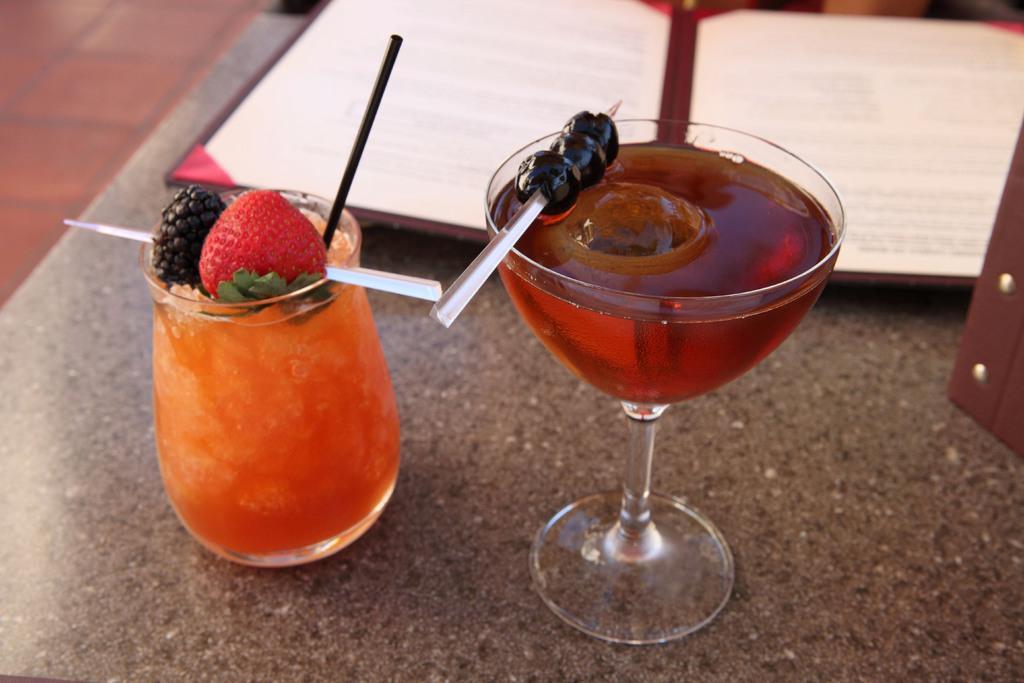Please provide a concise description of this image. In this image I see 2 glasses in which I see the orange color juice in this glass and I see a stick on which there is a strawberry and other fruit and I see the straw and in this glass I see the red color juice and on this stick I see the black ad I see the menu car over here and all these things are on a brown color surface. 